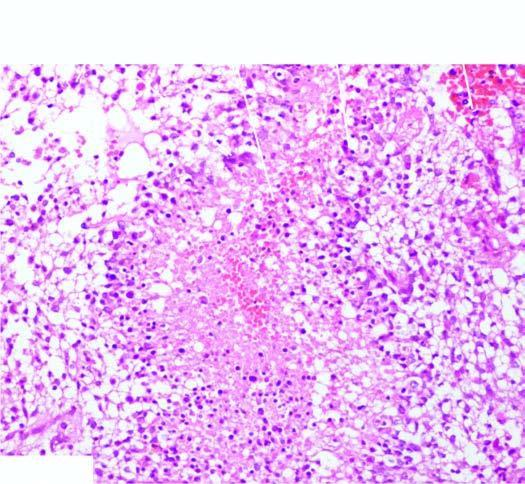what is densely cellular having marked pleomorphism?
Answer the question using a single word or phrase. Tumour 